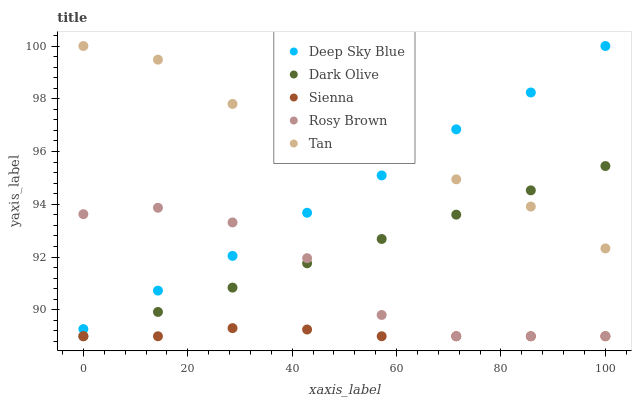Does Sienna have the minimum area under the curve?
Answer yes or no. Yes. Does Tan have the maximum area under the curve?
Answer yes or no. Yes. Does Rosy Brown have the minimum area under the curve?
Answer yes or no. No. Does Rosy Brown have the maximum area under the curve?
Answer yes or no. No. Is Dark Olive the smoothest?
Answer yes or no. Yes. Is Rosy Brown the roughest?
Answer yes or no. Yes. Is Rosy Brown the smoothest?
Answer yes or no. No. Is Dark Olive the roughest?
Answer yes or no. No. Does Sienna have the lowest value?
Answer yes or no. Yes. Does Tan have the lowest value?
Answer yes or no. No. Does Deep Sky Blue have the highest value?
Answer yes or no. Yes. Does Rosy Brown have the highest value?
Answer yes or no. No. Is Dark Olive less than Deep Sky Blue?
Answer yes or no. Yes. Is Tan greater than Rosy Brown?
Answer yes or no. Yes. Does Deep Sky Blue intersect Rosy Brown?
Answer yes or no. Yes. Is Deep Sky Blue less than Rosy Brown?
Answer yes or no. No. Is Deep Sky Blue greater than Rosy Brown?
Answer yes or no. No. Does Dark Olive intersect Deep Sky Blue?
Answer yes or no. No. 